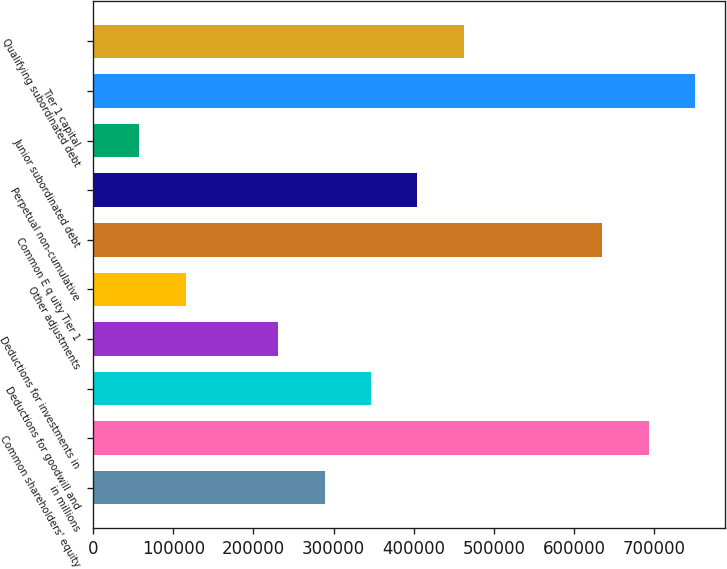<chart> <loc_0><loc_0><loc_500><loc_500><bar_chart><fcel>in millions<fcel>Common shareholders' equity<fcel>Deductions for goodwill and<fcel>Deductions for investments in<fcel>Other adjustments<fcel>Common E q uity Tier 1<fcel>Perpetual non-cumulative<fcel>Junior subordinated debt<fcel>Tier 1 capital<fcel>Qualifying subordinated debt<nl><fcel>288830<fcel>693179<fcel>346594<fcel>231066<fcel>115538<fcel>635415<fcel>404358<fcel>57773.5<fcel>750944<fcel>462123<nl></chart> 